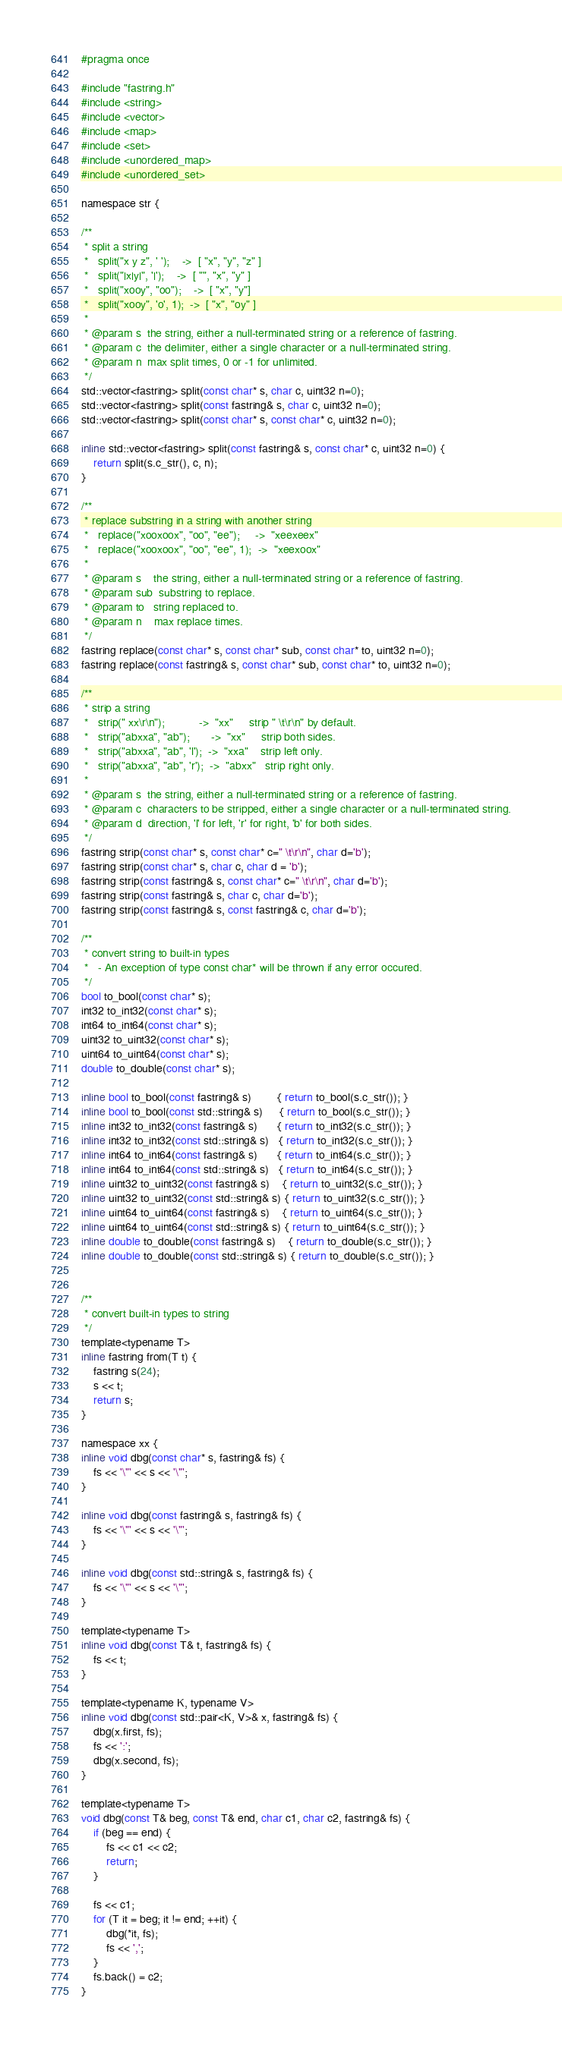<code> <loc_0><loc_0><loc_500><loc_500><_C_>#pragma once

#include "fastring.h"
#include <string>
#include <vector>
#include <map>
#include <set>
#include <unordered_map>
#include <unordered_set>

namespace str {

/**
 * split a string 
 *   split("x y z", ' ');    ->  [ "x", "y", "z" ]
 *   split("|x|y|", '|');    ->  [ "", "x", "y" ]
 *   split("xooy", "oo");    ->  [ "x", "y"]
 *   split("xooy", 'o', 1);  ->  [ "x", "oy" ]
 * 
 * @param s  the string, either a null-terminated string or a reference of fastring.
 * @param c  the delimiter, either a single character or a null-terminated string.
 * @param n  max split times, 0 or -1 for unlimited.
 */
std::vector<fastring> split(const char* s, char c, uint32 n=0);
std::vector<fastring> split(const fastring& s, char c, uint32 n=0);
std::vector<fastring> split(const char* s, const char* c, uint32 n=0);

inline std::vector<fastring> split(const fastring& s, const char* c, uint32 n=0) {
    return split(s.c_str(), c, n);
}

/**
 * replace substring in a string with another string 
 *   replace("xooxoox", "oo", "ee");     ->  "xeexeex" 
 *   replace("xooxoox", "oo", "ee", 1);  ->  "xeexoox" 
 * 
 * @param s    the string, either a null-terminated string or a reference of fastring.
 * @param sub  substring to replace.
 * @param to   string replaced to.
 * @param n    max replace times.
 */
fastring replace(const char* s, const char* sub, const char* to, uint32 n=0);
fastring replace(const fastring& s, const char* sub, const char* to, uint32 n=0);

/**
 * strip a string 
 *   strip(" xx\r\n");           ->  "xx"     strip " \t\r\n" by default. 
 *   strip("abxxa", "ab");       ->  "xx"     strip both sides. 
 *   strip("abxxa", "ab", 'l');  ->  "xxa"    strip left only. 
 *   strip("abxxa", "ab", 'r');  ->  "abxx"   strip right only. 
 * 
 * @param s  the string, either a null-terminated string or a reference of fastring.
 * @param c  characters to be stripped, either a single character or a null-terminated string.
 * @param d  direction, 'l' for left, 'r' for right, 'b' for both sides.
 */
fastring strip(const char* s, const char* c=" \t\r\n", char d='b');
fastring strip(const char* s, char c, char d = 'b');
fastring strip(const fastring& s, const char* c=" \t\r\n", char d='b');
fastring strip(const fastring& s, char c, char d='b');
fastring strip(const fastring& s, const fastring& c, char d='b');

/**
 * convert string to built-in types 
 *   - An exception of type const char* will be thrown if any error occured. 
 */
bool to_bool(const char* s);
int32 to_int32(const char* s);
int64 to_int64(const char* s);
uint32 to_uint32(const char* s);
uint64 to_uint64(const char* s);
double to_double(const char* s);

inline bool to_bool(const fastring& s)        { return to_bool(s.c_str()); }
inline bool to_bool(const std::string& s)     { return to_bool(s.c_str()); }
inline int32 to_int32(const fastring& s)      { return to_int32(s.c_str()); }
inline int32 to_int32(const std::string& s)   { return to_int32(s.c_str()); }
inline int64 to_int64(const fastring& s)      { return to_int64(s.c_str()); }
inline int64 to_int64(const std::string& s)   { return to_int64(s.c_str()); }
inline uint32 to_uint32(const fastring& s)    { return to_uint32(s.c_str()); }
inline uint32 to_uint32(const std::string& s) { return to_uint32(s.c_str()); }
inline uint64 to_uint64(const fastring& s)    { return to_uint64(s.c_str()); }
inline uint64 to_uint64(const std::string& s) { return to_uint64(s.c_str()); }
inline double to_double(const fastring& s)    { return to_double(s.c_str()); }
inline double to_double(const std::string& s) { return to_double(s.c_str()); }


/**
 * convert built-in types to string 
 */
template<typename T>
inline fastring from(T t) {
    fastring s(24);
    s << t;
    return s;
}

namespace xx {
inline void dbg(const char* s, fastring& fs) {
    fs << '\"' << s << '\"';
}

inline void dbg(const fastring& s, fastring& fs) {
    fs << '\"' << s << '\"';
}

inline void dbg(const std::string& s, fastring& fs) {
    fs << '\"' << s << '\"';
}

template<typename T>
inline void dbg(const T& t, fastring& fs) {
    fs << t;
}

template<typename K, typename V>
inline void dbg(const std::pair<K, V>& x, fastring& fs) {
    dbg(x.first, fs);
    fs << ':';
    dbg(x.second, fs);
}

template<typename T>
void dbg(const T& beg, const T& end, char c1, char c2, fastring& fs) {
    if (beg == end) {
        fs << c1 << c2;
        return;
    }

    fs << c1;
    for (T it = beg; it != end; ++it) {
        dbg(*it, fs);
        fs << ',';
    }
    fs.back() = c2;
}
</code> 